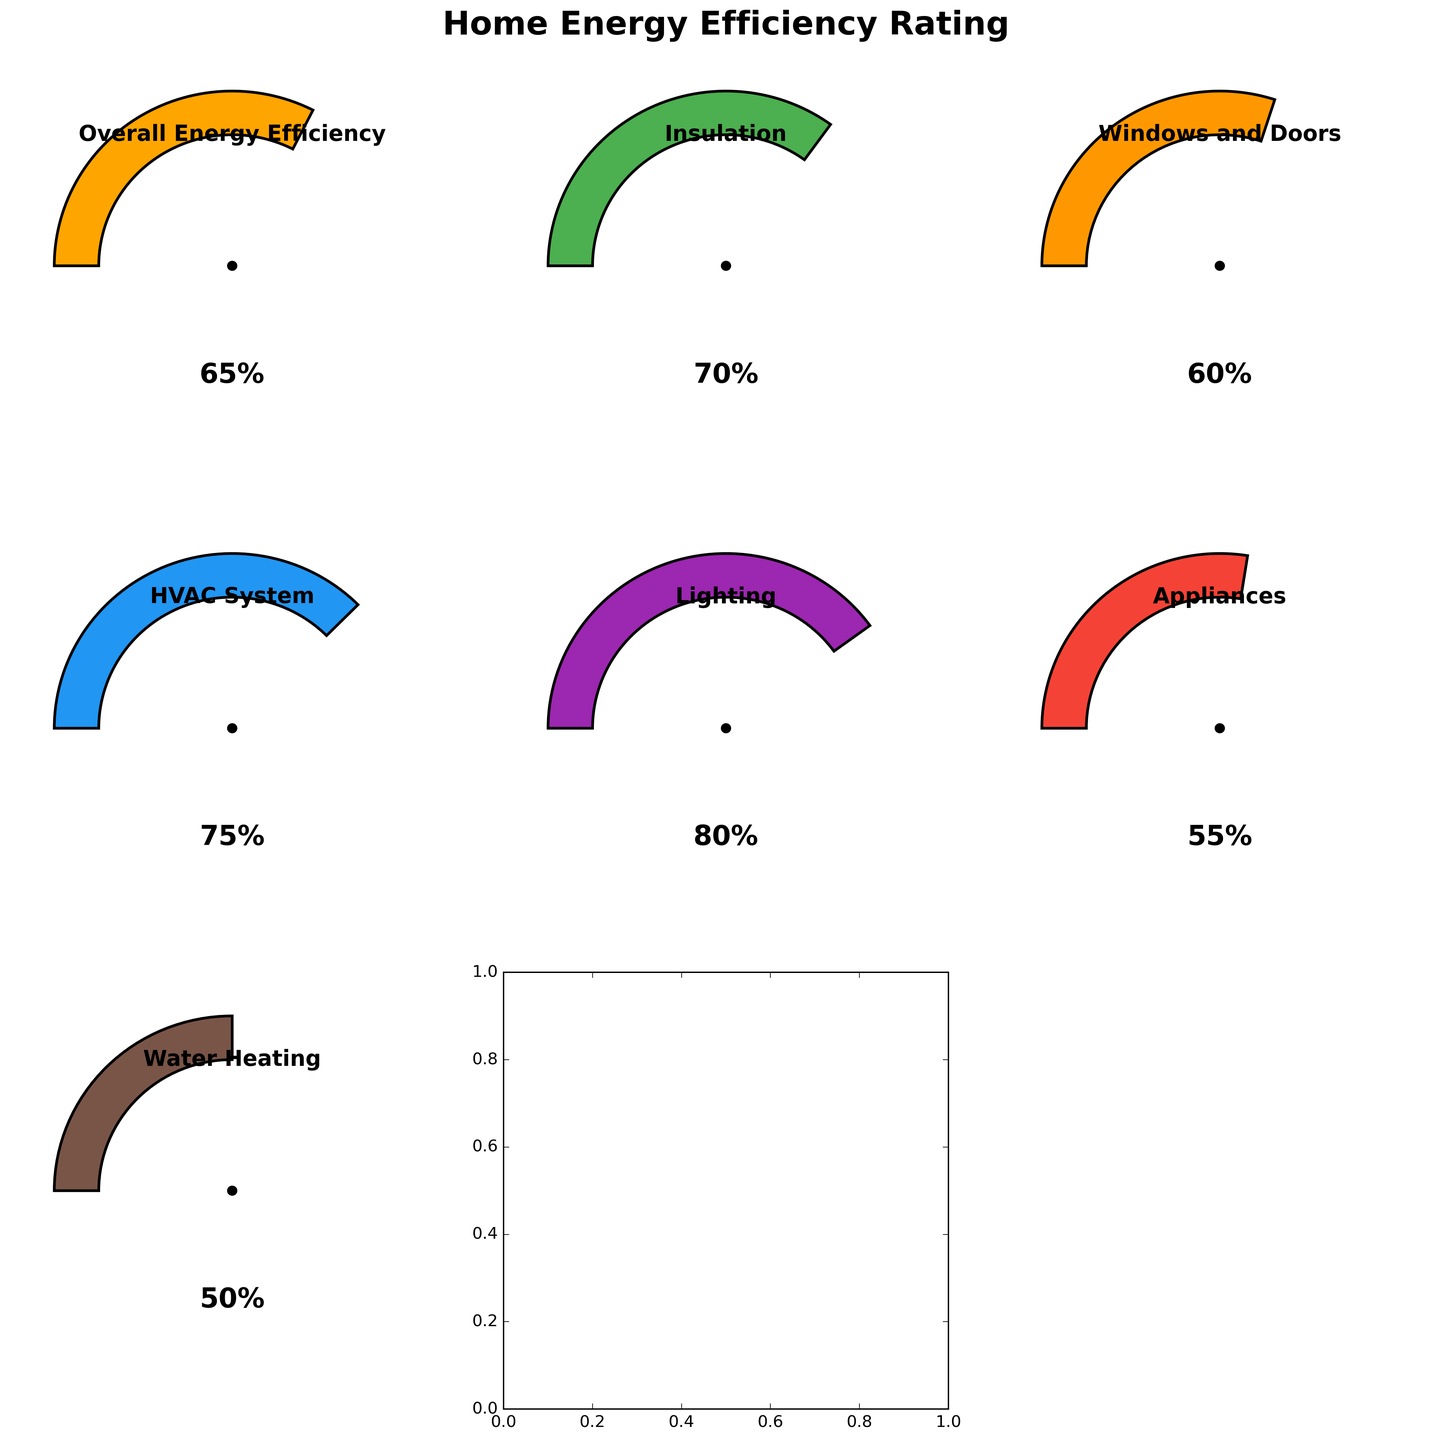What is the overall energy efficiency rating? Check the gauge labeled "Overall Energy Efficiency" and note the value displayed at the center.
Answer: 65% Which area of home energy efficiency has the highest rating? Compare the values displayed in the center of each gauge chart. The highest value is 80%, for "Lighting".
Answer: Lighting What is the difference between the ratings of Insulation and Appliances? Check the values for Insulation (70%) and Appliances (55%). Subtract the Appliance value from the Insulation value: 70% - 55% = 15%.
Answer: 15% If you improve Water Heating by 10%, what would its new rating be? Check the current value for Water Heating (50%) and add 10% to it: 50% + 10% = 60%.
Answer: 60% Which area needs the most improvement based on the current ratings? Identify the area with the lowest percentage. Water Heating has the lowest rating at 50%.
Answer: Water Heating How does the rating of the HVAC System compare to the rating of Windows and Doors? Compare the values for HVAC System (75%) and Windows and Doors (60%). HVAC System is rated higher.
Answer: Higher Are there any areas with a rating equal to or greater than 75%? Review the values, noting those that are 75% or higher. Both the HVAC System (75%) and Lighting (80%) meet this criterion.
Answer: Yes Which areas have ratings between 55% and 70% (inclusive)? Identify all areas within this range. They are Windows and Doors (60%) and Appliances (55%).
Answer: Windows and Doors, Appliances What is the average rating of all the areas combined? Sum all the ratings and divide by the number of areas: (65 + 70 + 60 + 75 + 80 + 55 + 50) / 7 = 455 / 7 ≈ 65%.
Answer: 65% If we raise the rating of Appliances by 20%, what will be the new rating? Check the current value (55%), then add 20%: 55% + 20% = 75%.
Answer: 75% 